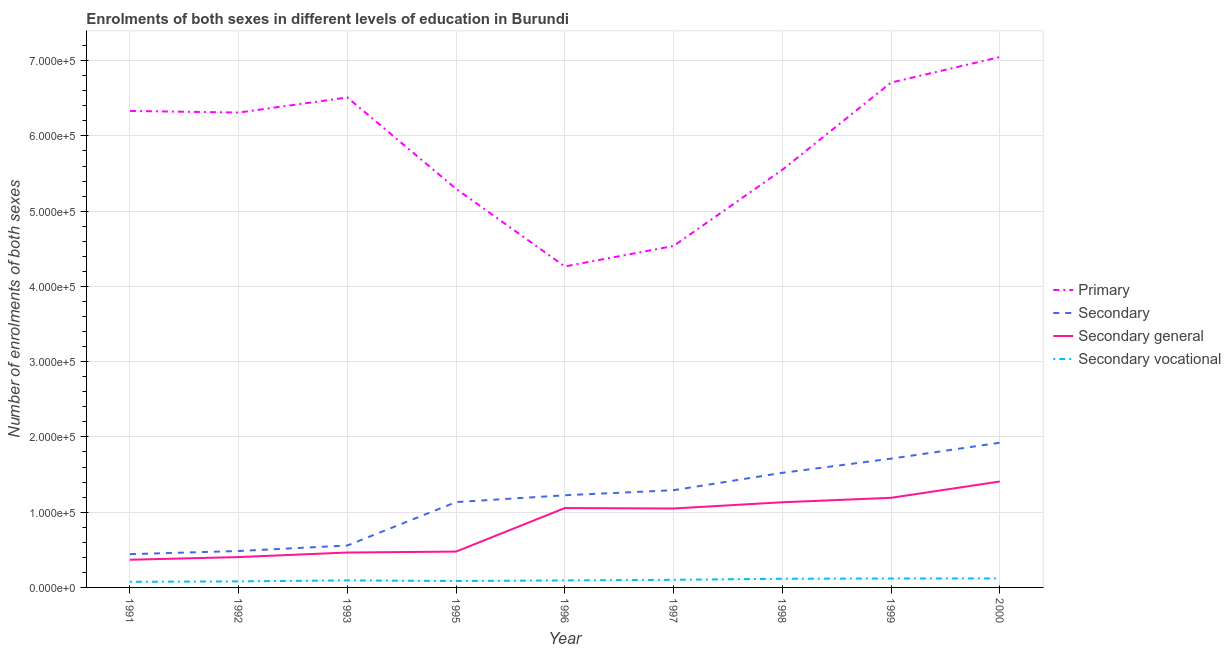How many different coloured lines are there?
Ensure brevity in your answer.  4. What is the number of enrolments in secondary education in 1999?
Provide a succinct answer. 1.71e+05. Across all years, what is the maximum number of enrolments in secondary vocational education?
Give a very brief answer. 1.19e+04. Across all years, what is the minimum number of enrolments in secondary vocational education?
Offer a terse response. 7434. In which year was the number of enrolments in secondary vocational education minimum?
Make the answer very short. 1991. What is the total number of enrolments in secondary vocational education in the graph?
Your answer should be compact. 8.81e+04. What is the difference between the number of enrolments in secondary general education in 1996 and that in 1998?
Your answer should be compact. -7703. What is the difference between the number of enrolments in secondary vocational education in 1993 and the number of enrolments in secondary education in 1998?
Provide a short and direct response. -1.43e+05. What is the average number of enrolments in secondary vocational education per year?
Ensure brevity in your answer.  9787.78. In the year 1997, what is the difference between the number of enrolments in secondary vocational education and number of enrolments in secondary general education?
Give a very brief answer. -9.48e+04. What is the ratio of the number of enrolments in primary education in 1997 to that in 2000?
Provide a succinct answer. 0.64. Is the number of enrolments in secondary general education in 1992 less than that in 1999?
Provide a succinct answer. Yes. What is the difference between the highest and the second highest number of enrolments in secondary vocational education?
Ensure brevity in your answer.  42. What is the difference between the highest and the lowest number of enrolments in secondary education?
Your answer should be compact. 1.48e+05. Is the sum of the number of enrolments in primary education in 1992 and 1997 greater than the maximum number of enrolments in secondary education across all years?
Provide a short and direct response. Yes. Is it the case that in every year, the sum of the number of enrolments in secondary vocational education and number of enrolments in primary education is greater than the sum of number of enrolments in secondary general education and number of enrolments in secondary education?
Provide a succinct answer. Yes. Does the number of enrolments in secondary vocational education monotonically increase over the years?
Ensure brevity in your answer.  No. Is the number of enrolments in secondary general education strictly greater than the number of enrolments in primary education over the years?
Your answer should be compact. No. What is the difference between two consecutive major ticks on the Y-axis?
Provide a short and direct response. 1.00e+05. Are the values on the major ticks of Y-axis written in scientific E-notation?
Your answer should be compact. Yes. Does the graph contain any zero values?
Your response must be concise. No. Does the graph contain grids?
Offer a terse response. Yes. What is the title of the graph?
Your answer should be compact. Enrolments of both sexes in different levels of education in Burundi. What is the label or title of the X-axis?
Offer a very short reply. Year. What is the label or title of the Y-axis?
Make the answer very short. Number of enrolments of both sexes. What is the Number of enrolments of both sexes in Primary in 1991?
Provide a short and direct response. 6.33e+05. What is the Number of enrolments of both sexes in Secondary in 1991?
Ensure brevity in your answer.  4.42e+04. What is the Number of enrolments of both sexes of Secondary general in 1991?
Provide a short and direct response. 3.68e+04. What is the Number of enrolments of both sexes in Secondary vocational in 1991?
Ensure brevity in your answer.  7434. What is the Number of enrolments of both sexes in Primary in 1992?
Your answer should be very brief. 6.31e+05. What is the Number of enrolments of both sexes in Secondary in 1992?
Give a very brief answer. 4.84e+04. What is the Number of enrolments of both sexes in Secondary general in 1992?
Provide a succinct answer. 4.03e+04. What is the Number of enrolments of both sexes of Secondary vocational in 1992?
Ensure brevity in your answer.  8064. What is the Number of enrolments of both sexes in Primary in 1993?
Keep it short and to the point. 6.51e+05. What is the Number of enrolments of both sexes in Secondary in 1993?
Keep it short and to the point. 5.57e+04. What is the Number of enrolments of both sexes of Secondary general in 1993?
Your answer should be compact. 4.64e+04. What is the Number of enrolments of both sexes in Secondary vocational in 1993?
Make the answer very short. 9332. What is the Number of enrolments of both sexes in Primary in 1995?
Your answer should be very brief. 5.30e+05. What is the Number of enrolments of both sexes in Secondary in 1995?
Make the answer very short. 1.13e+05. What is the Number of enrolments of both sexes in Secondary general in 1995?
Offer a very short reply. 4.76e+04. What is the Number of enrolments of both sexes of Secondary vocational in 1995?
Ensure brevity in your answer.  8542. What is the Number of enrolments of both sexes in Primary in 1996?
Ensure brevity in your answer.  4.27e+05. What is the Number of enrolments of both sexes of Secondary in 1996?
Offer a very short reply. 1.22e+05. What is the Number of enrolments of both sexes in Secondary general in 1996?
Provide a short and direct response. 1.05e+05. What is the Number of enrolments of both sexes in Secondary vocational in 1996?
Your answer should be compact. 9293. What is the Number of enrolments of both sexes in Primary in 1997?
Give a very brief answer. 4.54e+05. What is the Number of enrolments of both sexes of Secondary in 1997?
Offer a terse response. 1.29e+05. What is the Number of enrolments of both sexes of Secondary general in 1997?
Your answer should be compact. 1.05e+05. What is the Number of enrolments of both sexes in Secondary vocational in 1997?
Offer a very short reply. 1.01e+04. What is the Number of enrolments of both sexes of Primary in 1998?
Keep it short and to the point. 5.55e+05. What is the Number of enrolments of both sexes in Secondary in 1998?
Ensure brevity in your answer.  1.52e+05. What is the Number of enrolments of both sexes in Secondary general in 1998?
Your answer should be compact. 1.13e+05. What is the Number of enrolments of both sexes in Secondary vocational in 1998?
Ensure brevity in your answer.  1.15e+04. What is the Number of enrolments of both sexes of Primary in 1999?
Keep it short and to the point. 6.71e+05. What is the Number of enrolments of both sexes in Secondary in 1999?
Give a very brief answer. 1.71e+05. What is the Number of enrolments of both sexes in Secondary general in 1999?
Provide a succinct answer. 1.19e+05. What is the Number of enrolments of both sexes of Secondary vocational in 1999?
Offer a terse response. 1.19e+04. What is the Number of enrolments of both sexes of Primary in 2000?
Keep it short and to the point. 7.05e+05. What is the Number of enrolments of both sexes in Secondary in 2000?
Offer a very short reply. 1.92e+05. What is the Number of enrolments of both sexes in Secondary general in 2000?
Offer a very short reply. 1.41e+05. What is the Number of enrolments of both sexes in Secondary vocational in 2000?
Offer a terse response. 1.19e+04. Across all years, what is the maximum Number of enrolments of both sexes in Primary?
Your answer should be very brief. 7.05e+05. Across all years, what is the maximum Number of enrolments of both sexes of Secondary?
Give a very brief answer. 1.92e+05. Across all years, what is the maximum Number of enrolments of both sexes in Secondary general?
Your answer should be very brief. 1.41e+05. Across all years, what is the maximum Number of enrolments of both sexes in Secondary vocational?
Provide a short and direct response. 1.19e+04. Across all years, what is the minimum Number of enrolments of both sexes in Primary?
Make the answer very short. 4.27e+05. Across all years, what is the minimum Number of enrolments of both sexes in Secondary?
Make the answer very short. 4.42e+04. Across all years, what is the minimum Number of enrolments of both sexes in Secondary general?
Your response must be concise. 3.68e+04. Across all years, what is the minimum Number of enrolments of both sexes in Secondary vocational?
Make the answer very short. 7434. What is the total Number of enrolments of both sexes in Primary in the graph?
Give a very brief answer. 5.26e+06. What is the total Number of enrolments of both sexes of Secondary in the graph?
Make the answer very short. 1.03e+06. What is the total Number of enrolments of both sexes in Secondary general in the graph?
Offer a very short reply. 7.54e+05. What is the total Number of enrolments of both sexes in Secondary vocational in the graph?
Offer a very short reply. 8.81e+04. What is the difference between the Number of enrolments of both sexes in Primary in 1991 and that in 1992?
Your answer should be compact. 2164. What is the difference between the Number of enrolments of both sexes in Secondary in 1991 and that in 1992?
Offer a terse response. -4191. What is the difference between the Number of enrolments of both sexes in Secondary general in 1991 and that in 1992?
Your answer should be very brief. -3561. What is the difference between the Number of enrolments of both sexes of Secondary vocational in 1991 and that in 1992?
Provide a short and direct response. -630. What is the difference between the Number of enrolments of both sexes in Primary in 1991 and that in 1993?
Keep it short and to the point. -1.79e+04. What is the difference between the Number of enrolments of both sexes in Secondary in 1991 and that in 1993?
Your answer should be compact. -1.15e+04. What is the difference between the Number of enrolments of both sexes in Secondary general in 1991 and that in 1993?
Provide a succinct answer. -9608. What is the difference between the Number of enrolments of both sexes in Secondary vocational in 1991 and that in 1993?
Ensure brevity in your answer.  -1898. What is the difference between the Number of enrolments of both sexes in Primary in 1991 and that in 1995?
Ensure brevity in your answer.  1.04e+05. What is the difference between the Number of enrolments of both sexes in Secondary in 1991 and that in 1995?
Provide a short and direct response. -6.92e+04. What is the difference between the Number of enrolments of both sexes in Secondary general in 1991 and that in 1995?
Your answer should be very brief. -1.09e+04. What is the difference between the Number of enrolments of both sexes in Secondary vocational in 1991 and that in 1995?
Keep it short and to the point. -1108. What is the difference between the Number of enrolments of both sexes of Primary in 1991 and that in 1996?
Provide a succinct answer. 2.07e+05. What is the difference between the Number of enrolments of both sexes in Secondary in 1991 and that in 1996?
Your answer should be compact. -7.83e+04. What is the difference between the Number of enrolments of both sexes of Secondary general in 1991 and that in 1996?
Make the answer very short. -6.87e+04. What is the difference between the Number of enrolments of both sexes in Secondary vocational in 1991 and that in 1996?
Offer a very short reply. -1859. What is the difference between the Number of enrolments of both sexes in Primary in 1991 and that in 1997?
Your answer should be very brief. 1.79e+05. What is the difference between the Number of enrolments of both sexes in Secondary in 1991 and that in 1997?
Give a very brief answer. -8.50e+04. What is the difference between the Number of enrolments of both sexes of Secondary general in 1991 and that in 1997?
Keep it short and to the point. -6.81e+04. What is the difference between the Number of enrolments of both sexes in Secondary vocational in 1991 and that in 1997?
Make the answer very short. -2693. What is the difference between the Number of enrolments of both sexes in Primary in 1991 and that in 1998?
Give a very brief answer. 7.82e+04. What is the difference between the Number of enrolments of both sexes in Secondary in 1991 and that in 1998?
Make the answer very short. -1.08e+05. What is the difference between the Number of enrolments of both sexes in Secondary general in 1991 and that in 1998?
Offer a terse response. -7.64e+04. What is the difference between the Number of enrolments of both sexes of Secondary vocational in 1991 and that in 1998?
Give a very brief answer. -4082. What is the difference between the Number of enrolments of both sexes of Primary in 1991 and that in 1999?
Give a very brief answer. -3.77e+04. What is the difference between the Number of enrolments of both sexes of Secondary in 1991 and that in 1999?
Offer a terse response. -1.27e+05. What is the difference between the Number of enrolments of both sexes of Secondary general in 1991 and that in 1999?
Your response must be concise. -8.23e+04. What is the difference between the Number of enrolments of both sexes in Secondary vocational in 1991 and that in 1999?
Offer a very short reply. -4436. What is the difference between the Number of enrolments of both sexes in Primary in 1991 and that in 2000?
Ensure brevity in your answer.  -7.16e+04. What is the difference between the Number of enrolments of both sexes in Secondary in 1991 and that in 2000?
Offer a terse response. -1.48e+05. What is the difference between the Number of enrolments of both sexes of Secondary general in 1991 and that in 2000?
Offer a very short reply. -1.04e+05. What is the difference between the Number of enrolments of both sexes in Secondary vocational in 1991 and that in 2000?
Give a very brief answer. -4478. What is the difference between the Number of enrolments of both sexes of Primary in 1992 and that in 1993?
Give a very brief answer. -2.00e+04. What is the difference between the Number of enrolments of both sexes in Secondary in 1992 and that in 1993?
Offer a terse response. -7315. What is the difference between the Number of enrolments of both sexes of Secondary general in 1992 and that in 1993?
Offer a very short reply. -6047. What is the difference between the Number of enrolments of both sexes in Secondary vocational in 1992 and that in 1993?
Ensure brevity in your answer.  -1268. What is the difference between the Number of enrolments of both sexes of Primary in 1992 and that in 1995?
Make the answer very short. 1.01e+05. What is the difference between the Number of enrolments of both sexes in Secondary in 1992 and that in 1995?
Offer a terse response. -6.50e+04. What is the difference between the Number of enrolments of both sexes of Secondary general in 1992 and that in 1995?
Provide a short and direct response. -7302. What is the difference between the Number of enrolments of both sexes of Secondary vocational in 1992 and that in 1995?
Your response must be concise. -478. What is the difference between the Number of enrolments of both sexes in Primary in 1992 and that in 1996?
Keep it short and to the point. 2.05e+05. What is the difference between the Number of enrolments of both sexes in Secondary in 1992 and that in 1996?
Make the answer very short. -7.41e+04. What is the difference between the Number of enrolments of both sexes in Secondary general in 1992 and that in 1996?
Offer a very short reply. -6.51e+04. What is the difference between the Number of enrolments of both sexes of Secondary vocational in 1992 and that in 1996?
Offer a terse response. -1229. What is the difference between the Number of enrolments of both sexes in Primary in 1992 and that in 1997?
Make the answer very short. 1.77e+05. What is the difference between the Number of enrolments of both sexes in Secondary in 1992 and that in 1997?
Make the answer very short. -8.08e+04. What is the difference between the Number of enrolments of both sexes in Secondary general in 1992 and that in 1997?
Ensure brevity in your answer.  -6.46e+04. What is the difference between the Number of enrolments of both sexes in Secondary vocational in 1992 and that in 1997?
Provide a succinct answer. -2063. What is the difference between the Number of enrolments of both sexes in Primary in 1992 and that in 1998?
Ensure brevity in your answer.  7.61e+04. What is the difference between the Number of enrolments of both sexes of Secondary in 1992 and that in 1998?
Provide a short and direct response. -1.04e+05. What is the difference between the Number of enrolments of both sexes in Secondary general in 1992 and that in 1998?
Ensure brevity in your answer.  -7.28e+04. What is the difference between the Number of enrolments of both sexes of Secondary vocational in 1992 and that in 1998?
Offer a very short reply. -3452. What is the difference between the Number of enrolments of both sexes of Primary in 1992 and that in 1999?
Give a very brief answer. -3.98e+04. What is the difference between the Number of enrolments of both sexes of Secondary in 1992 and that in 1999?
Ensure brevity in your answer.  -1.23e+05. What is the difference between the Number of enrolments of both sexes of Secondary general in 1992 and that in 1999?
Offer a terse response. -7.87e+04. What is the difference between the Number of enrolments of both sexes of Secondary vocational in 1992 and that in 1999?
Keep it short and to the point. -3806. What is the difference between the Number of enrolments of both sexes of Primary in 1992 and that in 2000?
Your answer should be very brief. -7.37e+04. What is the difference between the Number of enrolments of both sexes in Secondary in 1992 and that in 2000?
Offer a terse response. -1.44e+05. What is the difference between the Number of enrolments of both sexes in Secondary general in 1992 and that in 2000?
Make the answer very short. -1.00e+05. What is the difference between the Number of enrolments of both sexes of Secondary vocational in 1992 and that in 2000?
Make the answer very short. -3848. What is the difference between the Number of enrolments of both sexes of Primary in 1993 and that in 1995?
Make the answer very short. 1.21e+05. What is the difference between the Number of enrolments of both sexes of Secondary in 1993 and that in 1995?
Provide a short and direct response. -5.77e+04. What is the difference between the Number of enrolments of both sexes of Secondary general in 1993 and that in 1995?
Keep it short and to the point. -1255. What is the difference between the Number of enrolments of both sexes of Secondary vocational in 1993 and that in 1995?
Give a very brief answer. 790. What is the difference between the Number of enrolments of both sexes of Primary in 1993 and that in 1996?
Your answer should be very brief. 2.25e+05. What is the difference between the Number of enrolments of both sexes of Secondary in 1993 and that in 1996?
Your answer should be very brief. -6.68e+04. What is the difference between the Number of enrolments of both sexes of Secondary general in 1993 and that in 1996?
Offer a very short reply. -5.91e+04. What is the difference between the Number of enrolments of both sexes in Primary in 1993 and that in 1997?
Offer a very short reply. 1.97e+05. What is the difference between the Number of enrolments of both sexes in Secondary in 1993 and that in 1997?
Provide a succinct answer. -7.35e+04. What is the difference between the Number of enrolments of both sexes of Secondary general in 1993 and that in 1997?
Provide a short and direct response. -5.85e+04. What is the difference between the Number of enrolments of both sexes in Secondary vocational in 1993 and that in 1997?
Keep it short and to the point. -795. What is the difference between the Number of enrolments of both sexes in Primary in 1993 and that in 1998?
Ensure brevity in your answer.  9.61e+04. What is the difference between the Number of enrolments of both sexes in Secondary in 1993 and that in 1998?
Make the answer very short. -9.65e+04. What is the difference between the Number of enrolments of both sexes in Secondary general in 1993 and that in 1998?
Offer a very short reply. -6.68e+04. What is the difference between the Number of enrolments of both sexes in Secondary vocational in 1993 and that in 1998?
Your answer should be compact. -2184. What is the difference between the Number of enrolments of both sexes of Primary in 1993 and that in 1999?
Offer a very short reply. -1.98e+04. What is the difference between the Number of enrolments of both sexes in Secondary in 1993 and that in 1999?
Provide a succinct answer. -1.15e+05. What is the difference between the Number of enrolments of both sexes in Secondary general in 1993 and that in 1999?
Offer a terse response. -7.27e+04. What is the difference between the Number of enrolments of both sexes of Secondary vocational in 1993 and that in 1999?
Make the answer very short. -2538. What is the difference between the Number of enrolments of both sexes of Primary in 1993 and that in 2000?
Your response must be concise. -5.37e+04. What is the difference between the Number of enrolments of both sexes of Secondary in 1993 and that in 2000?
Offer a very short reply. -1.37e+05. What is the difference between the Number of enrolments of both sexes in Secondary general in 1993 and that in 2000?
Provide a succinct answer. -9.44e+04. What is the difference between the Number of enrolments of both sexes in Secondary vocational in 1993 and that in 2000?
Your answer should be compact. -2580. What is the difference between the Number of enrolments of both sexes in Primary in 1995 and that in 1996?
Your response must be concise. 1.03e+05. What is the difference between the Number of enrolments of both sexes of Secondary in 1995 and that in 1996?
Offer a terse response. -9042. What is the difference between the Number of enrolments of both sexes of Secondary general in 1995 and that in 1996?
Offer a terse response. -5.78e+04. What is the difference between the Number of enrolments of both sexes in Secondary vocational in 1995 and that in 1996?
Your answer should be very brief. -751. What is the difference between the Number of enrolments of both sexes in Primary in 1995 and that in 1997?
Keep it short and to the point. 7.59e+04. What is the difference between the Number of enrolments of both sexes in Secondary in 1995 and that in 1997?
Provide a short and direct response. -1.58e+04. What is the difference between the Number of enrolments of both sexes of Secondary general in 1995 and that in 1997?
Offer a terse response. -5.72e+04. What is the difference between the Number of enrolments of both sexes of Secondary vocational in 1995 and that in 1997?
Give a very brief answer. -1585. What is the difference between the Number of enrolments of both sexes in Primary in 1995 and that in 1998?
Provide a succinct answer. -2.53e+04. What is the difference between the Number of enrolments of both sexes of Secondary in 1995 and that in 1998?
Your answer should be compact. -3.88e+04. What is the difference between the Number of enrolments of both sexes of Secondary general in 1995 and that in 1998?
Offer a terse response. -6.55e+04. What is the difference between the Number of enrolments of both sexes of Secondary vocational in 1995 and that in 1998?
Provide a short and direct response. -2974. What is the difference between the Number of enrolments of both sexes in Primary in 1995 and that in 1999?
Your response must be concise. -1.41e+05. What is the difference between the Number of enrolments of both sexes in Secondary in 1995 and that in 1999?
Your answer should be compact. -5.77e+04. What is the difference between the Number of enrolments of both sexes in Secondary general in 1995 and that in 1999?
Make the answer very short. -7.14e+04. What is the difference between the Number of enrolments of both sexes in Secondary vocational in 1995 and that in 1999?
Provide a succinct answer. -3328. What is the difference between the Number of enrolments of both sexes in Primary in 1995 and that in 2000?
Your answer should be very brief. -1.75e+05. What is the difference between the Number of enrolments of both sexes of Secondary in 1995 and that in 2000?
Give a very brief answer. -7.89e+04. What is the difference between the Number of enrolments of both sexes in Secondary general in 1995 and that in 2000?
Ensure brevity in your answer.  -9.31e+04. What is the difference between the Number of enrolments of both sexes of Secondary vocational in 1995 and that in 2000?
Provide a succinct answer. -3370. What is the difference between the Number of enrolments of both sexes of Primary in 1996 and that in 1997?
Make the answer very short. -2.72e+04. What is the difference between the Number of enrolments of both sexes of Secondary in 1996 and that in 1997?
Offer a terse response. -6735. What is the difference between the Number of enrolments of both sexes in Secondary general in 1996 and that in 1997?
Offer a terse response. 588. What is the difference between the Number of enrolments of both sexes of Secondary vocational in 1996 and that in 1997?
Give a very brief answer. -834. What is the difference between the Number of enrolments of both sexes in Primary in 1996 and that in 1998?
Give a very brief answer. -1.28e+05. What is the difference between the Number of enrolments of both sexes in Secondary in 1996 and that in 1998?
Offer a terse response. -2.98e+04. What is the difference between the Number of enrolments of both sexes in Secondary general in 1996 and that in 1998?
Offer a terse response. -7703. What is the difference between the Number of enrolments of both sexes of Secondary vocational in 1996 and that in 1998?
Ensure brevity in your answer.  -2223. What is the difference between the Number of enrolments of both sexes in Primary in 1996 and that in 1999?
Provide a succinct answer. -2.44e+05. What is the difference between the Number of enrolments of both sexes in Secondary in 1996 and that in 1999?
Offer a terse response. -4.86e+04. What is the difference between the Number of enrolments of both sexes of Secondary general in 1996 and that in 1999?
Offer a very short reply. -1.36e+04. What is the difference between the Number of enrolments of both sexes in Secondary vocational in 1996 and that in 1999?
Provide a short and direct response. -2577. What is the difference between the Number of enrolments of both sexes in Primary in 1996 and that in 2000?
Your response must be concise. -2.78e+05. What is the difference between the Number of enrolments of both sexes of Secondary in 1996 and that in 2000?
Provide a succinct answer. -6.98e+04. What is the difference between the Number of enrolments of both sexes of Secondary general in 1996 and that in 2000?
Make the answer very short. -3.53e+04. What is the difference between the Number of enrolments of both sexes in Secondary vocational in 1996 and that in 2000?
Make the answer very short. -2619. What is the difference between the Number of enrolments of both sexes in Primary in 1997 and that in 1998?
Provide a succinct answer. -1.01e+05. What is the difference between the Number of enrolments of both sexes in Secondary in 1997 and that in 1998?
Keep it short and to the point. -2.30e+04. What is the difference between the Number of enrolments of both sexes of Secondary general in 1997 and that in 1998?
Offer a terse response. -8291. What is the difference between the Number of enrolments of both sexes in Secondary vocational in 1997 and that in 1998?
Your answer should be very brief. -1389. What is the difference between the Number of enrolments of both sexes of Primary in 1997 and that in 1999?
Give a very brief answer. -2.17e+05. What is the difference between the Number of enrolments of both sexes of Secondary in 1997 and that in 1999?
Provide a succinct answer. -4.19e+04. What is the difference between the Number of enrolments of both sexes in Secondary general in 1997 and that in 1999?
Make the answer very short. -1.42e+04. What is the difference between the Number of enrolments of both sexes in Secondary vocational in 1997 and that in 1999?
Your answer should be compact. -1743. What is the difference between the Number of enrolments of both sexes of Primary in 1997 and that in 2000?
Make the answer very short. -2.51e+05. What is the difference between the Number of enrolments of both sexes of Secondary in 1997 and that in 2000?
Your answer should be compact. -6.31e+04. What is the difference between the Number of enrolments of both sexes of Secondary general in 1997 and that in 2000?
Ensure brevity in your answer.  -3.58e+04. What is the difference between the Number of enrolments of both sexes of Secondary vocational in 1997 and that in 2000?
Provide a succinct answer. -1785. What is the difference between the Number of enrolments of both sexes of Primary in 1998 and that in 1999?
Keep it short and to the point. -1.16e+05. What is the difference between the Number of enrolments of both sexes of Secondary in 1998 and that in 1999?
Keep it short and to the point. -1.89e+04. What is the difference between the Number of enrolments of both sexes of Secondary general in 1998 and that in 1999?
Your answer should be very brief. -5901. What is the difference between the Number of enrolments of both sexes in Secondary vocational in 1998 and that in 1999?
Provide a succinct answer. -354. What is the difference between the Number of enrolments of both sexes of Primary in 1998 and that in 2000?
Your response must be concise. -1.50e+05. What is the difference between the Number of enrolments of both sexes in Secondary in 1998 and that in 2000?
Give a very brief answer. -4.00e+04. What is the difference between the Number of enrolments of both sexes of Secondary general in 1998 and that in 2000?
Keep it short and to the point. -2.76e+04. What is the difference between the Number of enrolments of both sexes of Secondary vocational in 1998 and that in 2000?
Provide a succinct answer. -396. What is the difference between the Number of enrolments of both sexes of Primary in 1999 and that in 2000?
Your response must be concise. -3.39e+04. What is the difference between the Number of enrolments of both sexes in Secondary in 1999 and that in 2000?
Offer a terse response. -2.12e+04. What is the difference between the Number of enrolments of both sexes of Secondary general in 1999 and that in 2000?
Your answer should be very brief. -2.17e+04. What is the difference between the Number of enrolments of both sexes in Secondary vocational in 1999 and that in 2000?
Provide a short and direct response. -42. What is the difference between the Number of enrolments of both sexes in Primary in 1991 and the Number of enrolments of both sexes in Secondary in 1992?
Ensure brevity in your answer.  5.85e+05. What is the difference between the Number of enrolments of both sexes of Primary in 1991 and the Number of enrolments of both sexes of Secondary general in 1992?
Provide a short and direct response. 5.93e+05. What is the difference between the Number of enrolments of both sexes in Primary in 1991 and the Number of enrolments of both sexes in Secondary vocational in 1992?
Your answer should be very brief. 6.25e+05. What is the difference between the Number of enrolments of both sexes of Secondary in 1991 and the Number of enrolments of both sexes of Secondary general in 1992?
Your response must be concise. 3873. What is the difference between the Number of enrolments of both sexes in Secondary in 1991 and the Number of enrolments of both sexes in Secondary vocational in 1992?
Your answer should be very brief. 3.61e+04. What is the difference between the Number of enrolments of both sexes in Secondary general in 1991 and the Number of enrolments of both sexes in Secondary vocational in 1992?
Provide a short and direct response. 2.87e+04. What is the difference between the Number of enrolments of both sexes of Primary in 1991 and the Number of enrolments of both sexes of Secondary in 1993?
Give a very brief answer. 5.77e+05. What is the difference between the Number of enrolments of both sexes in Primary in 1991 and the Number of enrolments of both sexes in Secondary general in 1993?
Keep it short and to the point. 5.87e+05. What is the difference between the Number of enrolments of both sexes in Primary in 1991 and the Number of enrolments of both sexes in Secondary vocational in 1993?
Your response must be concise. 6.24e+05. What is the difference between the Number of enrolments of both sexes of Secondary in 1991 and the Number of enrolments of both sexes of Secondary general in 1993?
Your answer should be compact. -2174. What is the difference between the Number of enrolments of both sexes in Secondary in 1991 and the Number of enrolments of both sexes in Secondary vocational in 1993?
Make the answer very short. 3.49e+04. What is the difference between the Number of enrolments of both sexes in Secondary general in 1991 and the Number of enrolments of both sexes in Secondary vocational in 1993?
Provide a succinct answer. 2.74e+04. What is the difference between the Number of enrolments of both sexes of Primary in 1991 and the Number of enrolments of both sexes of Secondary in 1995?
Offer a very short reply. 5.20e+05. What is the difference between the Number of enrolments of both sexes of Primary in 1991 and the Number of enrolments of both sexes of Secondary general in 1995?
Ensure brevity in your answer.  5.86e+05. What is the difference between the Number of enrolments of both sexes of Primary in 1991 and the Number of enrolments of both sexes of Secondary vocational in 1995?
Ensure brevity in your answer.  6.25e+05. What is the difference between the Number of enrolments of both sexes in Secondary in 1991 and the Number of enrolments of both sexes in Secondary general in 1995?
Provide a short and direct response. -3429. What is the difference between the Number of enrolments of both sexes in Secondary in 1991 and the Number of enrolments of both sexes in Secondary vocational in 1995?
Provide a succinct answer. 3.57e+04. What is the difference between the Number of enrolments of both sexes in Secondary general in 1991 and the Number of enrolments of both sexes in Secondary vocational in 1995?
Offer a terse response. 2.82e+04. What is the difference between the Number of enrolments of both sexes in Primary in 1991 and the Number of enrolments of both sexes in Secondary in 1996?
Your response must be concise. 5.11e+05. What is the difference between the Number of enrolments of both sexes of Primary in 1991 and the Number of enrolments of both sexes of Secondary general in 1996?
Provide a succinct answer. 5.28e+05. What is the difference between the Number of enrolments of both sexes of Primary in 1991 and the Number of enrolments of both sexes of Secondary vocational in 1996?
Provide a short and direct response. 6.24e+05. What is the difference between the Number of enrolments of both sexes of Secondary in 1991 and the Number of enrolments of both sexes of Secondary general in 1996?
Offer a very short reply. -6.13e+04. What is the difference between the Number of enrolments of both sexes in Secondary in 1991 and the Number of enrolments of both sexes in Secondary vocational in 1996?
Provide a succinct answer. 3.49e+04. What is the difference between the Number of enrolments of both sexes of Secondary general in 1991 and the Number of enrolments of both sexes of Secondary vocational in 1996?
Provide a succinct answer. 2.75e+04. What is the difference between the Number of enrolments of both sexes of Primary in 1991 and the Number of enrolments of both sexes of Secondary in 1997?
Keep it short and to the point. 5.04e+05. What is the difference between the Number of enrolments of both sexes of Primary in 1991 and the Number of enrolments of both sexes of Secondary general in 1997?
Your answer should be very brief. 5.28e+05. What is the difference between the Number of enrolments of both sexes of Primary in 1991 and the Number of enrolments of both sexes of Secondary vocational in 1997?
Ensure brevity in your answer.  6.23e+05. What is the difference between the Number of enrolments of both sexes in Secondary in 1991 and the Number of enrolments of both sexes in Secondary general in 1997?
Your response must be concise. -6.07e+04. What is the difference between the Number of enrolments of both sexes of Secondary in 1991 and the Number of enrolments of both sexes of Secondary vocational in 1997?
Your answer should be compact. 3.41e+04. What is the difference between the Number of enrolments of both sexes in Secondary general in 1991 and the Number of enrolments of both sexes in Secondary vocational in 1997?
Your answer should be very brief. 2.66e+04. What is the difference between the Number of enrolments of both sexes in Primary in 1991 and the Number of enrolments of both sexes in Secondary in 1998?
Offer a very short reply. 4.81e+05. What is the difference between the Number of enrolments of both sexes of Primary in 1991 and the Number of enrolments of both sexes of Secondary general in 1998?
Your answer should be compact. 5.20e+05. What is the difference between the Number of enrolments of both sexes of Primary in 1991 and the Number of enrolments of both sexes of Secondary vocational in 1998?
Give a very brief answer. 6.22e+05. What is the difference between the Number of enrolments of both sexes in Secondary in 1991 and the Number of enrolments of both sexes in Secondary general in 1998?
Your answer should be compact. -6.90e+04. What is the difference between the Number of enrolments of both sexes in Secondary in 1991 and the Number of enrolments of both sexes in Secondary vocational in 1998?
Ensure brevity in your answer.  3.27e+04. What is the difference between the Number of enrolments of both sexes in Secondary general in 1991 and the Number of enrolments of both sexes in Secondary vocational in 1998?
Provide a short and direct response. 2.53e+04. What is the difference between the Number of enrolments of both sexes of Primary in 1991 and the Number of enrolments of both sexes of Secondary in 1999?
Offer a very short reply. 4.62e+05. What is the difference between the Number of enrolments of both sexes in Primary in 1991 and the Number of enrolments of both sexes in Secondary general in 1999?
Provide a succinct answer. 5.14e+05. What is the difference between the Number of enrolments of both sexes of Primary in 1991 and the Number of enrolments of both sexes of Secondary vocational in 1999?
Provide a succinct answer. 6.21e+05. What is the difference between the Number of enrolments of both sexes in Secondary in 1991 and the Number of enrolments of both sexes in Secondary general in 1999?
Give a very brief answer. -7.49e+04. What is the difference between the Number of enrolments of both sexes in Secondary in 1991 and the Number of enrolments of both sexes in Secondary vocational in 1999?
Provide a short and direct response. 3.23e+04. What is the difference between the Number of enrolments of both sexes of Secondary general in 1991 and the Number of enrolments of both sexes of Secondary vocational in 1999?
Make the answer very short. 2.49e+04. What is the difference between the Number of enrolments of both sexes in Primary in 1991 and the Number of enrolments of both sexes in Secondary in 2000?
Keep it short and to the point. 4.41e+05. What is the difference between the Number of enrolments of both sexes of Primary in 1991 and the Number of enrolments of both sexes of Secondary general in 2000?
Provide a short and direct response. 4.92e+05. What is the difference between the Number of enrolments of both sexes in Primary in 1991 and the Number of enrolments of both sexes in Secondary vocational in 2000?
Give a very brief answer. 6.21e+05. What is the difference between the Number of enrolments of both sexes of Secondary in 1991 and the Number of enrolments of both sexes of Secondary general in 2000?
Keep it short and to the point. -9.65e+04. What is the difference between the Number of enrolments of both sexes of Secondary in 1991 and the Number of enrolments of both sexes of Secondary vocational in 2000?
Your answer should be very brief. 3.23e+04. What is the difference between the Number of enrolments of both sexes in Secondary general in 1991 and the Number of enrolments of both sexes in Secondary vocational in 2000?
Your answer should be very brief. 2.49e+04. What is the difference between the Number of enrolments of both sexes in Primary in 1992 and the Number of enrolments of both sexes in Secondary in 1993?
Provide a succinct answer. 5.75e+05. What is the difference between the Number of enrolments of both sexes of Primary in 1992 and the Number of enrolments of both sexes of Secondary general in 1993?
Your response must be concise. 5.85e+05. What is the difference between the Number of enrolments of both sexes in Primary in 1992 and the Number of enrolments of both sexes in Secondary vocational in 1993?
Give a very brief answer. 6.22e+05. What is the difference between the Number of enrolments of both sexes in Secondary in 1992 and the Number of enrolments of both sexes in Secondary general in 1993?
Give a very brief answer. 2017. What is the difference between the Number of enrolments of both sexes in Secondary in 1992 and the Number of enrolments of both sexes in Secondary vocational in 1993?
Provide a succinct answer. 3.91e+04. What is the difference between the Number of enrolments of both sexes in Secondary general in 1992 and the Number of enrolments of both sexes in Secondary vocational in 1993?
Provide a short and direct response. 3.10e+04. What is the difference between the Number of enrolments of both sexes of Primary in 1992 and the Number of enrolments of both sexes of Secondary in 1995?
Give a very brief answer. 5.18e+05. What is the difference between the Number of enrolments of both sexes in Primary in 1992 and the Number of enrolments of both sexes in Secondary general in 1995?
Your answer should be compact. 5.83e+05. What is the difference between the Number of enrolments of both sexes in Primary in 1992 and the Number of enrolments of both sexes in Secondary vocational in 1995?
Keep it short and to the point. 6.22e+05. What is the difference between the Number of enrolments of both sexes in Secondary in 1992 and the Number of enrolments of both sexes in Secondary general in 1995?
Offer a terse response. 762. What is the difference between the Number of enrolments of both sexes of Secondary in 1992 and the Number of enrolments of both sexes of Secondary vocational in 1995?
Offer a very short reply. 3.99e+04. What is the difference between the Number of enrolments of both sexes in Secondary general in 1992 and the Number of enrolments of both sexes in Secondary vocational in 1995?
Provide a succinct answer. 3.18e+04. What is the difference between the Number of enrolments of both sexes in Primary in 1992 and the Number of enrolments of both sexes in Secondary in 1996?
Offer a very short reply. 5.09e+05. What is the difference between the Number of enrolments of both sexes of Primary in 1992 and the Number of enrolments of both sexes of Secondary general in 1996?
Provide a succinct answer. 5.26e+05. What is the difference between the Number of enrolments of both sexes in Primary in 1992 and the Number of enrolments of both sexes in Secondary vocational in 1996?
Keep it short and to the point. 6.22e+05. What is the difference between the Number of enrolments of both sexes of Secondary in 1992 and the Number of enrolments of both sexes of Secondary general in 1996?
Make the answer very short. -5.71e+04. What is the difference between the Number of enrolments of both sexes of Secondary in 1992 and the Number of enrolments of both sexes of Secondary vocational in 1996?
Offer a terse response. 3.91e+04. What is the difference between the Number of enrolments of both sexes in Secondary general in 1992 and the Number of enrolments of both sexes in Secondary vocational in 1996?
Keep it short and to the point. 3.10e+04. What is the difference between the Number of enrolments of both sexes of Primary in 1992 and the Number of enrolments of both sexes of Secondary in 1997?
Offer a terse response. 5.02e+05. What is the difference between the Number of enrolments of both sexes of Primary in 1992 and the Number of enrolments of both sexes of Secondary general in 1997?
Keep it short and to the point. 5.26e+05. What is the difference between the Number of enrolments of both sexes of Primary in 1992 and the Number of enrolments of both sexes of Secondary vocational in 1997?
Your response must be concise. 6.21e+05. What is the difference between the Number of enrolments of both sexes of Secondary in 1992 and the Number of enrolments of both sexes of Secondary general in 1997?
Your answer should be compact. -5.65e+04. What is the difference between the Number of enrolments of both sexes of Secondary in 1992 and the Number of enrolments of both sexes of Secondary vocational in 1997?
Provide a short and direct response. 3.83e+04. What is the difference between the Number of enrolments of both sexes in Secondary general in 1992 and the Number of enrolments of both sexes in Secondary vocational in 1997?
Provide a short and direct response. 3.02e+04. What is the difference between the Number of enrolments of both sexes in Primary in 1992 and the Number of enrolments of both sexes in Secondary in 1998?
Make the answer very short. 4.79e+05. What is the difference between the Number of enrolments of both sexes in Primary in 1992 and the Number of enrolments of both sexes in Secondary general in 1998?
Your answer should be very brief. 5.18e+05. What is the difference between the Number of enrolments of both sexes of Primary in 1992 and the Number of enrolments of both sexes of Secondary vocational in 1998?
Your answer should be compact. 6.20e+05. What is the difference between the Number of enrolments of both sexes of Secondary in 1992 and the Number of enrolments of both sexes of Secondary general in 1998?
Keep it short and to the point. -6.48e+04. What is the difference between the Number of enrolments of both sexes of Secondary in 1992 and the Number of enrolments of both sexes of Secondary vocational in 1998?
Provide a short and direct response. 3.69e+04. What is the difference between the Number of enrolments of both sexes in Secondary general in 1992 and the Number of enrolments of both sexes in Secondary vocational in 1998?
Provide a succinct answer. 2.88e+04. What is the difference between the Number of enrolments of both sexes of Primary in 1992 and the Number of enrolments of both sexes of Secondary in 1999?
Offer a very short reply. 4.60e+05. What is the difference between the Number of enrolments of both sexes in Primary in 1992 and the Number of enrolments of both sexes in Secondary general in 1999?
Your response must be concise. 5.12e+05. What is the difference between the Number of enrolments of both sexes of Primary in 1992 and the Number of enrolments of both sexes of Secondary vocational in 1999?
Provide a succinct answer. 6.19e+05. What is the difference between the Number of enrolments of both sexes of Secondary in 1992 and the Number of enrolments of both sexes of Secondary general in 1999?
Offer a terse response. -7.07e+04. What is the difference between the Number of enrolments of both sexes in Secondary in 1992 and the Number of enrolments of both sexes in Secondary vocational in 1999?
Offer a very short reply. 3.65e+04. What is the difference between the Number of enrolments of both sexes of Secondary general in 1992 and the Number of enrolments of both sexes of Secondary vocational in 1999?
Provide a short and direct response. 2.85e+04. What is the difference between the Number of enrolments of both sexes of Primary in 1992 and the Number of enrolments of both sexes of Secondary in 2000?
Provide a succinct answer. 4.39e+05. What is the difference between the Number of enrolments of both sexes of Primary in 1992 and the Number of enrolments of both sexes of Secondary general in 2000?
Offer a terse response. 4.90e+05. What is the difference between the Number of enrolments of both sexes in Primary in 1992 and the Number of enrolments of both sexes in Secondary vocational in 2000?
Your answer should be very brief. 6.19e+05. What is the difference between the Number of enrolments of both sexes in Secondary in 1992 and the Number of enrolments of both sexes in Secondary general in 2000?
Offer a very short reply. -9.23e+04. What is the difference between the Number of enrolments of both sexes in Secondary in 1992 and the Number of enrolments of both sexes in Secondary vocational in 2000?
Give a very brief answer. 3.65e+04. What is the difference between the Number of enrolments of both sexes in Secondary general in 1992 and the Number of enrolments of both sexes in Secondary vocational in 2000?
Offer a terse response. 2.84e+04. What is the difference between the Number of enrolments of both sexes in Primary in 1993 and the Number of enrolments of both sexes in Secondary in 1995?
Provide a succinct answer. 5.38e+05. What is the difference between the Number of enrolments of both sexes of Primary in 1993 and the Number of enrolments of both sexes of Secondary general in 1995?
Offer a terse response. 6.03e+05. What is the difference between the Number of enrolments of both sexes in Primary in 1993 and the Number of enrolments of both sexes in Secondary vocational in 1995?
Provide a succinct answer. 6.43e+05. What is the difference between the Number of enrolments of both sexes of Secondary in 1993 and the Number of enrolments of both sexes of Secondary general in 1995?
Provide a short and direct response. 8077. What is the difference between the Number of enrolments of both sexes of Secondary in 1993 and the Number of enrolments of both sexes of Secondary vocational in 1995?
Offer a terse response. 4.72e+04. What is the difference between the Number of enrolments of both sexes in Secondary general in 1993 and the Number of enrolments of both sexes in Secondary vocational in 1995?
Provide a succinct answer. 3.78e+04. What is the difference between the Number of enrolments of both sexes in Primary in 1993 and the Number of enrolments of both sexes in Secondary in 1996?
Keep it short and to the point. 5.29e+05. What is the difference between the Number of enrolments of both sexes in Primary in 1993 and the Number of enrolments of both sexes in Secondary general in 1996?
Make the answer very short. 5.46e+05. What is the difference between the Number of enrolments of both sexes in Primary in 1993 and the Number of enrolments of both sexes in Secondary vocational in 1996?
Provide a short and direct response. 6.42e+05. What is the difference between the Number of enrolments of both sexes in Secondary in 1993 and the Number of enrolments of both sexes in Secondary general in 1996?
Your answer should be very brief. -4.98e+04. What is the difference between the Number of enrolments of both sexes in Secondary in 1993 and the Number of enrolments of both sexes in Secondary vocational in 1996?
Offer a terse response. 4.64e+04. What is the difference between the Number of enrolments of both sexes in Secondary general in 1993 and the Number of enrolments of both sexes in Secondary vocational in 1996?
Make the answer very short. 3.71e+04. What is the difference between the Number of enrolments of both sexes in Primary in 1993 and the Number of enrolments of both sexes in Secondary in 1997?
Ensure brevity in your answer.  5.22e+05. What is the difference between the Number of enrolments of both sexes in Primary in 1993 and the Number of enrolments of both sexes in Secondary general in 1997?
Your answer should be very brief. 5.46e+05. What is the difference between the Number of enrolments of both sexes of Primary in 1993 and the Number of enrolments of both sexes of Secondary vocational in 1997?
Provide a short and direct response. 6.41e+05. What is the difference between the Number of enrolments of both sexes in Secondary in 1993 and the Number of enrolments of both sexes in Secondary general in 1997?
Your response must be concise. -4.92e+04. What is the difference between the Number of enrolments of both sexes of Secondary in 1993 and the Number of enrolments of both sexes of Secondary vocational in 1997?
Offer a very short reply. 4.56e+04. What is the difference between the Number of enrolments of both sexes of Secondary general in 1993 and the Number of enrolments of both sexes of Secondary vocational in 1997?
Provide a succinct answer. 3.63e+04. What is the difference between the Number of enrolments of both sexes of Primary in 1993 and the Number of enrolments of both sexes of Secondary in 1998?
Offer a very short reply. 4.99e+05. What is the difference between the Number of enrolments of both sexes of Primary in 1993 and the Number of enrolments of both sexes of Secondary general in 1998?
Offer a very short reply. 5.38e+05. What is the difference between the Number of enrolments of both sexes of Primary in 1993 and the Number of enrolments of both sexes of Secondary vocational in 1998?
Keep it short and to the point. 6.40e+05. What is the difference between the Number of enrolments of both sexes of Secondary in 1993 and the Number of enrolments of both sexes of Secondary general in 1998?
Keep it short and to the point. -5.75e+04. What is the difference between the Number of enrolments of both sexes of Secondary in 1993 and the Number of enrolments of both sexes of Secondary vocational in 1998?
Make the answer very short. 4.42e+04. What is the difference between the Number of enrolments of both sexes of Secondary general in 1993 and the Number of enrolments of both sexes of Secondary vocational in 1998?
Provide a short and direct response. 3.49e+04. What is the difference between the Number of enrolments of both sexes in Primary in 1993 and the Number of enrolments of both sexes in Secondary in 1999?
Your answer should be very brief. 4.80e+05. What is the difference between the Number of enrolments of both sexes in Primary in 1993 and the Number of enrolments of both sexes in Secondary general in 1999?
Give a very brief answer. 5.32e+05. What is the difference between the Number of enrolments of both sexes of Primary in 1993 and the Number of enrolments of both sexes of Secondary vocational in 1999?
Provide a short and direct response. 6.39e+05. What is the difference between the Number of enrolments of both sexes of Secondary in 1993 and the Number of enrolments of both sexes of Secondary general in 1999?
Give a very brief answer. -6.34e+04. What is the difference between the Number of enrolments of both sexes in Secondary in 1993 and the Number of enrolments of both sexes in Secondary vocational in 1999?
Your answer should be compact. 4.38e+04. What is the difference between the Number of enrolments of both sexes of Secondary general in 1993 and the Number of enrolments of both sexes of Secondary vocational in 1999?
Your response must be concise. 3.45e+04. What is the difference between the Number of enrolments of both sexes in Primary in 1993 and the Number of enrolments of both sexes in Secondary in 2000?
Provide a succinct answer. 4.59e+05. What is the difference between the Number of enrolments of both sexes of Primary in 1993 and the Number of enrolments of both sexes of Secondary general in 2000?
Provide a short and direct response. 5.10e+05. What is the difference between the Number of enrolments of both sexes in Primary in 1993 and the Number of enrolments of both sexes in Secondary vocational in 2000?
Make the answer very short. 6.39e+05. What is the difference between the Number of enrolments of both sexes in Secondary in 1993 and the Number of enrolments of both sexes in Secondary general in 2000?
Your answer should be compact. -8.50e+04. What is the difference between the Number of enrolments of both sexes of Secondary in 1993 and the Number of enrolments of both sexes of Secondary vocational in 2000?
Offer a terse response. 4.38e+04. What is the difference between the Number of enrolments of both sexes of Secondary general in 1993 and the Number of enrolments of both sexes of Secondary vocational in 2000?
Offer a terse response. 3.45e+04. What is the difference between the Number of enrolments of both sexes of Primary in 1995 and the Number of enrolments of both sexes of Secondary in 1996?
Offer a terse response. 4.07e+05. What is the difference between the Number of enrolments of both sexes of Primary in 1995 and the Number of enrolments of both sexes of Secondary general in 1996?
Your response must be concise. 4.24e+05. What is the difference between the Number of enrolments of both sexes in Primary in 1995 and the Number of enrolments of both sexes in Secondary vocational in 1996?
Your response must be concise. 5.20e+05. What is the difference between the Number of enrolments of both sexes of Secondary in 1995 and the Number of enrolments of both sexes of Secondary general in 1996?
Your answer should be compact. 7954. What is the difference between the Number of enrolments of both sexes of Secondary in 1995 and the Number of enrolments of both sexes of Secondary vocational in 1996?
Give a very brief answer. 1.04e+05. What is the difference between the Number of enrolments of both sexes of Secondary general in 1995 and the Number of enrolments of both sexes of Secondary vocational in 1996?
Provide a succinct answer. 3.83e+04. What is the difference between the Number of enrolments of both sexes in Primary in 1995 and the Number of enrolments of both sexes in Secondary in 1997?
Offer a very short reply. 4.00e+05. What is the difference between the Number of enrolments of both sexes in Primary in 1995 and the Number of enrolments of both sexes in Secondary general in 1997?
Your answer should be very brief. 4.25e+05. What is the difference between the Number of enrolments of both sexes of Primary in 1995 and the Number of enrolments of both sexes of Secondary vocational in 1997?
Your answer should be very brief. 5.20e+05. What is the difference between the Number of enrolments of both sexes of Secondary in 1995 and the Number of enrolments of both sexes of Secondary general in 1997?
Give a very brief answer. 8542. What is the difference between the Number of enrolments of both sexes in Secondary in 1995 and the Number of enrolments of both sexes in Secondary vocational in 1997?
Ensure brevity in your answer.  1.03e+05. What is the difference between the Number of enrolments of both sexes of Secondary general in 1995 and the Number of enrolments of both sexes of Secondary vocational in 1997?
Offer a very short reply. 3.75e+04. What is the difference between the Number of enrolments of both sexes in Primary in 1995 and the Number of enrolments of both sexes in Secondary in 1998?
Your answer should be very brief. 3.77e+05. What is the difference between the Number of enrolments of both sexes of Primary in 1995 and the Number of enrolments of both sexes of Secondary general in 1998?
Provide a short and direct response. 4.16e+05. What is the difference between the Number of enrolments of both sexes of Primary in 1995 and the Number of enrolments of both sexes of Secondary vocational in 1998?
Offer a very short reply. 5.18e+05. What is the difference between the Number of enrolments of both sexes in Secondary in 1995 and the Number of enrolments of both sexes in Secondary general in 1998?
Offer a terse response. 251. What is the difference between the Number of enrolments of both sexes of Secondary in 1995 and the Number of enrolments of both sexes of Secondary vocational in 1998?
Offer a terse response. 1.02e+05. What is the difference between the Number of enrolments of both sexes in Secondary general in 1995 and the Number of enrolments of both sexes in Secondary vocational in 1998?
Ensure brevity in your answer.  3.61e+04. What is the difference between the Number of enrolments of both sexes of Primary in 1995 and the Number of enrolments of both sexes of Secondary in 1999?
Keep it short and to the point. 3.59e+05. What is the difference between the Number of enrolments of both sexes in Primary in 1995 and the Number of enrolments of both sexes in Secondary general in 1999?
Ensure brevity in your answer.  4.11e+05. What is the difference between the Number of enrolments of both sexes in Primary in 1995 and the Number of enrolments of both sexes in Secondary vocational in 1999?
Offer a very short reply. 5.18e+05. What is the difference between the Number of enrolments of both sexes of Secondary in 1995 and the Number of enrolments of both sexes of Secondary general in 1999?
Offer a terse response. -5650. What is the difference between the Number of enrolments of both sexes in Secondary in 1995 and the Number of enrolments of both sexes in Secondary vocational in 1999?
Offer a very short reply. 1.02e+05. What is the difference between the Number of enrolments of both sexes of Secondary general in 1995 and the Number of enrolments of both sexes of Secondary vocational in 1999?
Make the answer very short. 3.58e+04. What is the difference between the Number of enrolments of both sexes in Primary in 1995 and the Number of enrolments of both sexes in Secondary in 2000?
Your answer should be very brief. 3.37e+05. What is the difference between the Number of enrolments of both sexes of Primary in 1995 and the Number of enrolments of both sexes of Secondary general in 2000?
Give a very brief answer. 3.89e+05. What is the difference between the Number of enrolments of both sexes in Primary in 1995 and the Number of enrolments of both sexes in Secondary vocational in 2000?
Offer a terse response. 5.18e+05. What is the difference between the Number of enrolments of both sexes of Secondary in 1995 and the Number of enrolments of both sexes of Secondary general in 2000?
Your response must be concise. -2.73e+04. What is the difference between the Number of enrolments of both sexes in Secondary in 1995 and the Number of enrolments of both sexes in Secondary vocational in 2000?
Give a very brief answer. 1.02e+05. What is the difference between the Number of enrolments of both sexes of Secondary general in 1995 and the Number of enrolments of both sexes of Secondary vocational in 2000?
Your answer should be very brief. 3.57e+04. What is the difference between the Number of enrolments of both sexes in Primary in 1996 and the Number of enrolments of both sexes in Secondary in 1997?
Provide a succinct answer. 2.97e+05. What is the difference between the Number of enrolments of both sexes in Primary in 1996 and the Number of enrolments of both sexes in Secondary general in 1997?
Provide a short and direct response. 3.22e+05. What is the difference between the Number of enrolments of both sexes in Primary in 1996 and the Number of enrolments of both sexes in Secondary vocational in 1997?
Keep it short and to the point. 4.16e+05. What is the difference between the Number of enrolments of both sexes in Secondary in 1996 and the Number of enrolments of both sexes in Secondary general in 1997?
Your answer should be compact. 1.76e+04. What is the difference between the Number of enrolments of both sexes of Secondary in 1996 and the Number of enrolments of both sexes of Secondary vocational in 1997?
Ensure brevity in your answer.  1.12e+05. What is the difference between the Number of enrolments of both sexes of Secondary general in 1996 and the Number of enrolments of both sexes of Secondary vocational in 1997?
Your answer should be compact. 9.53e+04. What is the difference between the Number of enrolments of both sexes of Primary in 1996 and the Number of enrolments of both sexes of Secondary in 1998?
Ensure brevity in your answer.  2.74e+05. What is the difference between the Number of enrolments of both sexes in Primary in 1996 and the Number of enrolments of both sexes in Secondary general in 1998?
Your response must be concise. 3.13e+05. What is the difference between the Number of enrolments of both sexes in Primary in 1996 and the Number of enrolments of both sexes in Secondary vocational in 1998?
Give a very brief answer. 4.15e+05. What is the difference between the Number of enrolments of both sexes of Secondary in 1996 and the Number of enrolments of both sexes of Secondary general in 1998?
Offer a very short reply. 9293. What is the difference between the Number of enrolments of both sexes in Secondary in 1996 and the Number of enrolments of both sexes in Secondary vocational in 1998?
Make the answer very short. 1.11e+05. What is the difference between the Number of enrolments of both sexes in Secondary general in 1996 and the Number of enrolments of both sexes in Secondary vocational in 1998?
Your answer should be compact. 9.40e+04. What is the difference between the Number of enrolments of both sexes of Primary in 1996 and the Number of enrolments of both sexes of Secondary in 1999?
Keep it short and to the point. 2.55e+05. What is the difference between the Number of enrolments of both sexes of Primary in 1996 and the Number of enrolments of both sexes of Secondary general in 1999?
Make the answer very short. 3.07e+05. What is the difference between the Number of enrolments of both sexes of Primary in 1996 and the Number of enrolments of both sexes of Secondary vocational in 1999?
Provide a short and direct response. 4.15e+05. What is the difference between the Number of enrolments of both sexes in Secondary in 1996 and the Number of enrolments of both sexes in Secondary general in 1999?
Your answer should be very brief. 3392. What is the difference between the Number of enrolments of both sexes in Secondary in 1996 and the Number of enrolments of both sexes in Secondary vocational in 1999?
Your response must be concise. 1.11e+05. What is the difference between the Number of enrolments of both sexes in Secondary general in 1996 and the Number of enrolments of both sexes in Secondary vocational in 1999?
Keep it short and to the point. 9.36e+04. What is the difference between the Number of enrolments of both sexes of Primary in 1996 and the Number of enrolments of both sexes of Secondary in 2000?
Your response must be concise. 2.34e+05. What is the difference between the Number of enrolments of both sexes in Primary in 1996 and the Number of enrolments of both sexes in Secondary general in 2000?
Provide a succinct answer. 2.86e+05. What is the difference between the Number of enrolments of both sexes of Primary in 1996 and the Number of enrolments of both sexes of Secondary vocational in 2000?
Keep it short and to the point. 4.15e+05. What is the difference between the Number of enrolments of both sexes of Secondary in 1996 and the Number of enrolments of both sexes of Secondary general in 2000?
Offer a very short reply. -1.83e+04. What is the difference between the Number of enrolments of both sexes in Secondary in 1996 and the Number of enrolments of both sexes in Secondary vocational in 2000?
Keep it short and to the point. 1.11e+05. What is the difference between the Number of enrolments of both sexes of Secondary general in 1996 and the Number of enrolments of both sexes of Secondary vocational in 2000?
Offer a very short reply. 9.36e+04. What is the difference between the Number of enrolments of both sexes in Primary in 1997 and the Number of enrolments of both sexes in Secondary in 1998?
Offer a very short reply. 3.01e+05. What is the difference between the Number of enrolments of both sexes of Primary in 1997 and the Number of enrolments of both sexes of Secondary general in 1998?
Provide a short and direct response. 3.41e+05. What is the difference between the Number of enrolments of both sexes in Primary in 1997 and the Number of enrolments of both sexes in Secondary vocational in 1998?
Give a very brief answer. 4.42e+05. What is the difference between the Number of enrolments of both sexes in Secondary in 1997 and the Number of enrolments of both sexes in Secondary general in 1998?
Make the answer very short. 1.60e+04. What is the difference between the Number of enrolments of both sexes in Secondary in 1997 and the Number of enrolments of both sexes in Secondary vocational in 1998?
Make the answer very short. 1.18e+05. What is the difference between the Number of enrolments of both sexes in Secondary general in 1997 and the Number of enrolments of both sexes in Secondary vocational in 1998?
Provide a succinct answer. 9.34e+04. What is the difference between the Number of enrolments of both sexes of Primary in 1997 and the Number of enrolments of both sexes of Secondary in 1999?
Your response must be concise. 2.83e+05. What is the difference between the Number of enrolments of both sexes in Primary in 1997 and the Number of enrolments of both sexes in Secondary general in 1999?
Offer a terse response. 3.35e+05. What is the difference between the Number of enrolments of both sexes of Primary in 1997 and the Number of enrolments of both sexes of Secondary vocational in 1999?
Offer a terse response. 4.42e+05. What is the difference between the Number of enrolments of both sexes of Secondary in 1997 and the Number of enrolments of both sexes of Secondary general in 1999?
Your answer should be very brief. 1.01e+04. What is the difference between the Number of enrolments of both sexes of Secondary in 1997 and the Number of enrolments of both sexes of Secondary vocational in 1999?
Provide a short and direct response. 1.17e+05. What is the difference between the Number of enrolments of both sexes in Secondary general in 1997 and the Number of enrolments of both sexes in Secondary vocational in 1999?
Provide a succinct answer. 9.30e+04. What is the difference between the Number of enrolments of both sexes in Primary in 1997 and the Number of enrolments of both sexes in Secondary in 2000?
Provide a short and direct response. 2.61e+05. What is the difference between the Number of enrolments of both sexes in Primary in 1997 and the Number of enrolments of both sexes in Secondary general in 2000?
Provide a succinct answer. 3.13e+05. What is the difference between the Number of enrolments of both sexes in Primary in 1997 and the Number of enrolments of both sexes in Secondary vocational in 2000?
Keep it short and to the point. 4.42e+05. What is the difference between the Number of enrolments of both sexes in Secondary in 1997 and the Number of enrolments of both sexes in Secondary general in 2000?
Keep it short and to the point. -1.15e+04. What is the difference between the Number of enrolments of both sexes in Secondary in 1997 and the Number of enrolments of both sexes in Secondary vocational in 2000?
Provide a succinct answer. 1.17e+05. What is the difference between the Number of enrolments of both sexes in Secondary general in 1997 and the Number of enrolments of both sexes in Secondary vocational in 2000?
Your answer should be compact. 9.30e+04. What is the difference between the Number of enrolments of both sexes of Primary in 1998 and the Number of enrolments of both sexes of Secondary in 1999?
Your answer should be compact. 3.84e+05. What is the difference between the Number of enrolments of both sexes of Primary in 1998 and the Number of enrolments of both sexes of Secondary general in 1999?
Offer a very short reply. 4.36e+05. What is the difference between the Number of enrolments of both sexes of Primary in 1998 and the Number of enrolments of both sexes of Secondary vocational in 1999?
Provide a short and direct response. 5.43e+05. What is the difference between the Number of enrolments of both sexes in Secondary in 1998 and the Number of enrolments of both sexes in Secondary general in 1999?
Offer a terse response. 3.32e+04. What is the difference between the Number of enrolments of both sexes of Secondary in 1998 and the Number of enrolments of both sexes of Secondary vocational in 1999?
Offer a terse response. 1.40e+05. What is the difference between the Number of enrolments of both sexes of Secondary general in 1998 and the Number of enrolments of both sexes of Secondary vocational in 1999?
Your response must be concise. 1.01e+05. What is the difference between the Number of enrolments of both sexes of Primary in 1998 and the Number of enrolments of both sexes of Secondary in 2000?
Your response must be concise. 3.63e+05. What is the difference between the Number of enrolments of both sexes of Primary in 1998 and the Number of enrolments of both sexes of Secondary general in 2000?
Make the answer very short. 4.14e+05. What is the difference between the Number of enrolments of both sexes in Primary in 1998 and the Number of enrolments of both sexes in Secondary vocational in 2000?
Give a very brief answer. 5.43e+05. What is the difference between the Number of enrolments of both sexes of Secondary in 1998 and the Number of enrolments of both sexes of Secondary general in 2000?
Provide a succinct answer. 1.15e+04. What is the difference between the Number of enrolments of both sexes of Secondary in 1998 and the Number of enrolments of both sexes of Secondary vocational in 2000?
Ensure brevity in your answer.  1.40e+05. What is the difference between the Number of enrolments of both sexes in Secondary general in 1998 and the Number of enrolments of both sexes in Secondary vocational in 2000?
Offer a terse response. 1.01e+05. What is the difference between the Number of enrolments of both sexes in Primary in 1999 and the Number of enrolments of both sexes in Secondary in 2000?
Provide a succinct answer. 4.79e+05. What is the difference between the Number of enrolments of both sexes of Primary in 1999 and the Number of enrolments of both sexes of Secondary general in 2000?
Your answer should be compact. 5.30e+05. What is the difference between the Number of enrolments of both sexes in Primary in 1999 and the Number of enrolments of both sexes in Secondary vocational in 2000?
Give a very brief answer. 6.59e+05. What is the difference between the Number of enrolments of both sexes in Secondary in 1999 and the Number of enrolments of both sexes in Secondary general in 2000?
Give a very brief answer. 3.04e+04. What is the difference between the Number of enrolments of both sexes of Secondary in 1999 and the Number of enrolments of both sexes of Secondary vocational in 2000?
Your answer should be compact. 1.59e+05. What is the difference between the Number of enrolments of both sexes in Secondary general in 1999 and the Number of enrolments of both sexes in Secondary vocational in 2000?
Provide a short and direct response. 1.07e+05. What is the average Number of enrolments of both sexes of Primary per year?
Your response must be concise. 5.84e+05. What is the average Number of enrolments of both sexes in Secondary per year?
Ensure brevity in your answer.  1.14e+05. What is the average Number of enrolments of both sexes of Secondary general per year?
Your answer should be compact. 8.38e+04. What is the average Number of enrolments of both sexes of Secondary vocational per year?
Your answer should be very brief. 9787.78. In the year 1991, what is the difference between the Number of enrolments of both sexes in Primary and Number of enrolments of both sexes in Secondary?
Give a very brief answer. 5.89e+05. In the year 1991, what is the difference between the Number of enrolments of both sexes in Primary and Number of enrolments of both sexes in Secondary general?
Provide a succinct answer. 5.96e+05. In the year 1991, what is the difference between the Number of enrolments of both sexes in Primary and Number of enrolments of both sexes in Secondary vocational?
Your answer should be very brief. 6.26e+05. In the year 1991, what is the difference between the Number of enrolments of both sexes of Secondary and Number of enrolments of both sexes of Secondary general?
Provide a short and direct response. 7434. In the year 1991, what is the difference between the Number of enrolments of both sexes in Secondary and Number of enrolments of both sexes in Secondary vocational?
Make the answer very short. 3.68e+04. In the year 1991, what is the difference between the Number of enrolments of both sexes in Secondary general and Number of enrolments of both sexes in Secondary vocational?
Your answer should be compact. 2.93e+04. In the year 1992, what is the difference between the Number of enrolments of both sexes of Primary and Number of enrolments of both sexes of Secondary?
Ensure brevity in your answer.  5.83e+05. In the year 1992, what is the difference between the Number of enrolments of both sexes of Primary and Number of enrolments of both sexes of Secondary general?
Your response must be concise. 5.91e+05. In the year 1992, what is the difference between the Number of enrolments of both sexes of Primary and Number of enrolments of both sexes of Secondary vocational?
Make the answer very short. 6.23e+05. In the year 1992, what is the difference between the Number of enrolments of both sexes in Secondary and Number of enrolments of both sexes in Secondary general?
Your response must be concise. 8064. In the year 1992, what is the difference between the Number of enrolments of both sexes of Secondary and Number of enrolments of both sexes of Secondary vocational?
Make the answer very short. 4.03e+04. In the year 1992, what is the difference between the Number of enrolments of both sexes in Secondary general and Number of enrolments of both sexes in Secondary vocational?
Your answer should be compact. 3.23e+04. In the year 1993, what is the difference between the Number of enrolments of both sexes of Primary and Number of enrolments of both sexes of Secondary?
Provide a short and direct response. 5.95e+05. In the year 1993, what is the difference between the Number of enrolments of both sexes in Primary and Number of enrolments of both sexes in Secondary general?
Keep it short and to the point. 6.05e+05. In the year 1993, what is the difference between the Number of enrolments of both sexes of Primary and Number of enrolments of both sexes of Secondary vocational?
Make the answer very short. 6.42e+05. In the year 1993, what is the difference between the Number of enrolments of both sexes in Secondary and Number of enrolments of both sexes in Secondary general?
Your answer should be compact. 9332. In the year 1993, what is the difference between the Number of enrolments of both sexes of Secondary and Number of enrolments of both sexes of Secondary vocational?
Your answer should be very brief. 4.64e+04. In the year 1993, what is the difference between the Number of enrolments of both sexes of Secondary general and Number of enrolments of both sexes of Secondary vocational?
Your answer should be very brief. 3.70e+04. In the year 1995, what is the difference between the Number of enrolments of both sexes of Primary and Number of enrolments of both sexes of Secondary?
Provide a short and direct response. 4.16e+05. In the year 1995, what is the difference between the Number of enrolments of both sexes in Primary and Number of enrolments of both sexes in Secondary general?
Your response must be concise. 4.82e+05. In the year 1995, what is the difference between the Number of enrolments of both sexes of Primary and Number of enrolments of both sexes of Secondary vocational?
Make the answer very short. 5.21e+05. In the year 1995, what is the difference between the Number of enrolments of both sexes of Secondary and Number of enrolments of both sexes of Secondary general?
Offer a terse response. 6.58e+04. In the year 1995, what is the difference between the Number of enrolments of both sexes of Secondary and Number of enrolments of both sexes of Secondary vocational?
Keep it short and to the point. 1.05e+05. In the year 1995, what is the difference between the Number of enrolments of both sexes in Secondary general and Number of enrolments of both sexes in Secondary vocational?
Provide a succinct answer. 3.91e+04. In the year 1996, what is the difference between the Number of enrolments of both sexes in Primary and Number of enrolments of both sexes in Secondary?
Offer a very short reply. 3.04e+05. In the year 1996, what is the difference between the Number of enrolments of both sexes in Primary and Number of enrolments of both sexes in Secondary general?
Your answer should be compact. 3.21e+05. In the year 1996, what is the difference between the Number of enrolments of both sexes of Primary and Number of enrolments of both sexes of Secondary vocational?
Offer a terse response. 4.17e+05. In the year 1996, what is the difference between the Number of enrolments of both sexes of Secondary and Number of enrolments of both sexes of Secondary general?
Ensure brevity in your answer.  1.70e+04. In the year 1996, what is the difference between the Number of enrolments of both sexes of Secondary and Number of enrolments of both sexes of Secondary vocational?
Keep it short and to the point. 1.13e+05. In the year 1996, what is the difference between the Number of enrolments of both sexes of Secondary general and Number of enrolments of both sexes of Secondary vocational?
Ensure brevity in your answer.  9.62e+04. In the year 1997, what is the difference between the Number of enrolments of both sexes of Primary and Number of enrolments of both sexes of Secondary?
Provide a succinct answer. 3.25e+05. In the year 1997, what is the difference between the Number of enrolments of both sexes of Primary and Number of enrolments of both sexes of Secondary general?
Provide a short and direct response. 3.49e+05. In the year 1997, what is the difference between the Number of enrolments of both sexes in Primary and Number of enrolments of both sexes in Secondary vocational?
Your answer should be compact. 4.44e+05. In the year 1997, what is the difference between the Number of enrolments of both sexes of Secondary and Number of enrolments of both sexes of Secondary general?
Offer a terse response. 2.43e+04. In the year 1997, what is the difference between the Number of enrolments of both sexes of Secondary and Number of enrolments of both sexes of Secondary vocational?
Offer a terse response. 1.19e+05. In the year 1997, what is the difference between the Number of enrolments of both sexes in Secondary general and Number of enrolments of both sexes in Secondary vocational?
Your answer should be compact. 9.48e+04. In the year 1998, what is the difference between the Number of enrolments of both sexes of Primary and Number of enrolments of both sexes of Secondary?
Your response must be concise. 4.03e+05. In the year 1998, what is the difference between the Number of enrolments of both sexes in Primary and Number of enrolments of both sexes in Secondary general?
Provide a short and direct response. 4.42e+05. In the year 1998, what is the difference between the Number of enrolments of both sexes in Primary and Number of enrolments of both sexes in Secondary vocational?
Ensure brevity in your answer.  5.43e+05. In the year 1998, what is the difference between the Number of enrolments of both sexes in Secondary and Number of enrolments of both sexes in Secondary general?
Your response must be concise. 3.91e+04. In the year 1998, what is the difference between the Number of enrolments of both sexes of Secondary and Number of enrolments of both sexes of Secondary vocational?
Offer a very short reply. 1.41e+05. In the year 1998, what is the difference between the Number of enrolments of both sexes of Secondary general and Number of enrolments of both sexes of Secondary vocational?
Ensure brevity in your answer.  1.02e+05. In the year 1999, what is the difference between the Number of enrolments of both sexes of Primary and Number of enrolments of both sexes of Secondary?
Your answer should be very brief. 5.00e+05. In the year 1999, what is the difference between the Number of enrolments of both sexes of Primary and Number of enrolments of both sexes of Secondary general?
Give a very brief answer. 5.52e+05. In the year 1999, what is the difference between the Number of enrolments of both sexes of Primary and Number of enrolments of both sexes of Secondary vocational?
Your answer should be compact. 6.59e+05. In the year 1999, what is the difference between the Number of enrolments of both sexes in Secondary and Number of enrolments of both sexes in Secondary general?
Your answer should be compact. 5.20e+04. In the year 1999, what is the difference between the Number of enrolments of both sexes in Secondary and Number of enrolments of both sexes in Secondary vocational?
Ensure brevity in your answer.  1.59e+05. In the year 1999, what is the difference between the Number of enrolments of both sexes of Secondary general and Number of enrolments of both sexes of Secondary vocational?
Provide a short and direct response. 1.07e+05. In the year 2000, what is the difference between the Number of enrolments of both sexes of Primary and Number of enrolments of both sexes of Secondary?
Your response must be concise. 5.12e+05. In the year 2000, what is the difference between the Number of enrolments of both sexes in Primary and Number of enrolments of both sexes in Secondary general?
Provide a short and direct response. 5.64e+05. In the year 2000, what is the difference between the Number of enrolments of both sexes in Primary and Number of enrolments of both sexes in Secondary vocational?
Ensure brevity in your answer.  6.93e+05. In the year 2000, what is the difference between the Number of enrolments of both sexes in Secondary and Number of enrolments of both sexes in Secondary general?
Keep it short and to the point. 5.16e+04. In the year 2000, what is the difference between the Number of enrolments of both sexes in Secondary and Number of enrolments of both sexes in Secondary vocational?
Make the answer very short. 1.80e+05. In the year 2000, what is the difference between the Number of enrolments of both sexes in Secondary general and Number of enrolments of both sexes in Secondary vocational?
Ensure brevity in your answer.  1.29e+05. What is the ratio of the Number of enrolments of both sexes of Primary in 1991 to that in 1992?
Ensure brevity in your answer.  1. What is the ratio of the Number of enrolments of both sexes in Secondary in 1991 to that in 1992?
Keep it short and to the point. 0.91. What is the ratio of the Number of enrolments of both sexes of Secondary general in 1991 to that in 1992?
Provide a short and direct response. 0.91. What is the ratio of the Number of enrolments of both sexes in Secondary vocational in 1991 to that in 1992?
Your answer should be very brief. 0.92. What is the ratio of the Number of enrolments of both sexes of Primary in 1991 to that in 1993?
Your answer should be compact. 0.97. What is the ratio of the Number of enrolments of both sexes of Secondary in 1991 to that in 1993?
Give a very brief answer. 0.79. What is the ratio of the Number of enrolments of both sexes of Secondary general in 1991 to that in 1993?
Your answer should be very brief. 0.79. What is the ratio of the Number of enrolments of both sexes in Secondary vocational in 1991 to that in 1993?
Make the answer very short. 0.8. What is the ratio of the Number of enrolments of both sexes in Primary in 1991 to that in 1995?
Offer a very short reply. 1.2. What is the ratio of the Number of enrolments of both sexes in Secondary in 1991 to that in 1995?
Give a very brief answer. 0.39. What is the ratio of the Number of enrolments of both sexes in Secondary general in 1991 to that in 1995?
Make the answer very short. 0.77. What is the ratio of the Number of enrolments of both sexes of Secondary vocational in 1991 to that in 1995?
Offer a very short reply. 0.87. What is the ratio of the Number of enrolments of both sexes of Primary in 1991 to that in 1996?
Give a very brief answer. 1.48. What is the ratio of the Number of enrolments of both sexes in Secondary in 1991 to that in 1996?
Give a very brief answer. 0.36. What is the ratio of the Number of enrolments of both sexes of Secondary general in 1991 to that in 1996?
Your response must be concise. 0.35. What is the ratio of the Number of enrolments of both sexes in Primary in 1991 to that in 1997?
Your answer should be compact. 1.4. What is the ratio of the Number of enrolments of both sexes of Secondary in 1991 to that in 1997?
Your answer should be very brief. 0.34. What is the ratio of the Number of enrolments of both sexes of Secondary general in 1991 to that in 1997?
Your answer should be compact. 0.35. What is the ratio of the Number of enrolments of both sexes of Secondary vocational in 1991 to that in 1997?
Your answer should be compact. 0.73. What is the ratio of the Number of enrolments of both sexes of Primary in 1991 to that in 1998?
Keep it short and to the point. 1.14. What is the ratio of the Number of enrolments of both sexes in Secondary in 1991 to that in 1998?
Give a very brief answer. 0.29. What is the ratio of the Number of enrolments of both sexes of Secondary general in 1991 to that in 1998?
Your response must be concise. 0.32. What is the ratio of the Number of enrolments of both sexes in Secondary vocational in 1991 to that in 1998?
Provide a short and direct response. 0.65. What is the ratio of the Number of enrolments of both sexes in Primary in 1991 to that in 1999?
Your answer should be compact. 0.94. What is the ratio of the Number of enrolments of both sexes in Secondary in 1991 to that in 1999?
Your response must be concise. 0.26. What is the ratio of the Number of enrolments of both sexes of Secondary general in 1991 to that in 1999?
Your answer should be very brief. 0.31. What is the ratio of the Number of enrolments of both sexes of Secondary vocational in 1991 to that in 1999?
Your response must be concise. 0.63. What is the ratio of the Number of enrolments of both sexes of Primary in 1991 to that in 2000?
Keep it short and to the point. 0.9. What is the ratio of the Number of enrolments of both sexes of Secondary in 1991 to that in 2000?
Your answer should be very brief. 0.23. What is the ratio of the Number of enrolments of both sexes in Secondary general in 1991 to that in 2000?
Provide a succinct answer. 0.26. What is the ratio of the Number of enrolments of both sexes of Secondary vocational in 1991 to that in 2000?
Offer a terse response. 0.62. What is the ratio of the Number of enrolments of both sexes in Primary in 1992 to that in 1993?
Your answer should be very brief. 0.97. What is the ratio of the Number of enrolments of both sexes of Secondary in 1992 to that in 1993?
Your response must be concise. 0.87. What is the ratio of the Number of enrolments of both sexes of Secondary general in 1992 to that in 1993?
Keep it short and to the point. 0.87. What is the ratio of the Number of enrolments of both sexes in Secondary vocational in 1992 to that in 1993?
Provide a succinct answer. 0.86. What is the ratio of the Number of enrolments of both sexes in Primary in 1992 to that in 1995?
Keep it short and to the point. 1.19. What is the ratio of the Number of enrolments of both sexes of Secondary in 1992 to that in 1995?
Offer a very short reply. 0.43. What is the ratio of the Number of enrolments of both sexes of Secondary general in 1992 to that in 1995?
Offer a terse response. 0.85. What is the ratio of the Number of enrolments of both sexes in Secondary vocational in 1992 to that in 1995?
Your answer should be very brief. 0.94. What is the ratio of the Number of enrolments of both sexes of Primary in 1992 to that in 1996?
Your response must be concise. 1.48. What is the ratio of the Number of enrolments of both sexes of Secondary in 1992 to that in 1996?
Your answer should be compact. 0.4. What is the ratio of the Number of enrolments of both sexes in Secondary general in 1992 to that in 1996?
Keep it short and to the point. 0.38. What is the ratio of the Number of enrolments of both sexes in Secondary vocational in 1992 to that in 1996?
Provide a succinct answer. 0.87. What is the ratio of the Number of enrolments of both sexes in Primary in 1992 to that in 1997?
Your response must be concise. 1.39. What is the ratio of the Number of enrolments of both sexes of Secondary in 1992 to that in 1997?
Provide a short and direct response. 0.37. What is the ratio of the Number of enrolments of both sexes in Secondary general in 1992 to that in 1997?
Provide a succinct answer. 0.38. What is the ratio of the Number of enrolments of both sexes of Secondary vocational in 1992 to that in 1997?
Your answer should be compact. 0.8. What is the ratio of the Number of enrolments of both sexes of Primary in 1992 to that in 1998?
Make the answer very short. 1.14. What is the ratio of the Number of enrolments of both sexes in Secondary in 1992 to that in 1998?
Provide a short and direct response. 0.32. What is the ratio of the Number of enrolments of both sexes in Secondary general in 1992 to that in 1998?
Give a very brief answer. 0.36. What is the ratio of the Number of enrolments of both sexes in Secondary vocational in 1992 to that in 1998?
Your answer should be very brief. 0.7. What is the ratio of the Number of enrolments of both sexes in Primary in 1992 to that in 1999?
Your answer should be very brief. 0.94. What is the ratio of the Number of enrolments of both sexes of Secondary in 1992 to that in 1999?
Make the answer very short. 0.28. What is the ratio of the Number of enrolments of both sexes of Secondary general in 1992 to that in 1999?
Offer a very short reply. 0.34. What is the ratio of the Number of enrolments of both sexes in Secondary vocational in 1992 to that in 1999?
Make the answer very short. 0.68. What is the ratio of the Number of enrolments of both sexes of Primary in 1992 to that in 2000?
Offer a very short reply. 0.9. What is the ratio of the Number of enrolments of both sexes in Secondary in 1992 to that in 2000?
Make the answer very short. 0.25. What is the ratio of the Number of enrolments of both sexes in Secondary general in 1992 to that in 2000?
Offer a terse response. 0.29. What is the ratio of the Number of enrolments of both sexes of Secondary vocational in 1992 to that in 2000?
Keep it short and to the point. 0.68. What is the ratio of the Number of enrolments of both sexes of Primary in 1993 to that in 1995?
Offer a terse response. 1.23. What is the ratio of the Number of enrolments of both sexes in Secondary in 1993 to that in 1995?
Offer a terse response. 0.49. What is the ratio of the Number of enrolments of both sexes of Secondary general in 1993 to that in 1995?
Provide a short and direct response. 0.97. What is the ratio of the Number of enrolments of both sexes in Secondary vocational in 1993 to that in 1995?
Your response must be concise. 1.09. What is the ratio of the Number of enrolments of both sexes of Primary in 1993 to that in 1996?
Make the answer very short. 1.53. What is the ratio of the Number of enrolments of both sexes in Secondary in 1993 to that in 1996?
Your answer should be compact. 0.45. What is the ratio of the Number of enrolments of both sexes of Secondary general in 1993 to that in 1996?
Give a very brief answer. 0.44. What is the ratio of the Number of enrolments of both sexes of Primary in 1993 to that in 1997?
Make the answer very short. 1.43. What is the ratio of the Number of enrolments of both sexes in Secondary in 1993 to that in 1997?
Give a very brief answer. 0.43. What is the ratio of the Number of enrolments of both sexes in Secondary general in 1993 to that in 1997?
Your response must be concise. 0.44. What is the ratio of the Number of enrolments of both sexes of Secondary vocational in 1993 to that in 1997?
Offer a terse response. 0.92. What is the ratio of the Number of enrolments of both sexes in Primary in 1993 to that in 1998?
Ensure brevity in your answer.  1.17. What is the ratio of the Number of enrolments of both sexes in Secondary in 1993 to that in 1998?
Provide a short and direct response. 0.37. What is the ratio of the Number of enrolments of both sexes of Secondary general in 1993 to that in 1998?
Offer a terse response. 0.41. What is the ratio of the Number of enrolments of both sexes of Secondary vocational in 1993 to that in 1998?
Provide a short and direct response. 0.81. What is the ratio of the Number of enrolments of both sexes in Primary in 1993 to that in 1999?
Your answer should be compact. 0.97. What is the ratio of the Number of enrolments of both sexes of Secondary in 1993 to that in 1999?
Provide a succinct answer. 0.33. What is the ratio of the Number of enrolments of both sexes of Secondary general in 1993 to that in 1999?
Give a very brief answer. 0.39. What is the ratio of the Number of enrolments of both sexes of Secondary vocational in 1993 to that in 1999?
Keep it short and to the point. 0.79. What is the ratio of the Number of enrolments of both sexes of Primary in 1993 to that in 2000?
Your response must be concise. 0.92. What is the ratio of the Number of enrolments of both sexes of Secondary in 1993 to that in 2000?
Offer a very short reply. 0.29. What is the ratio of the Number of enrolments of both sexes of Secondary general in 1993 to that in 2000?
Provide a succinct answer. 0.33. What is the ratio of the Number of enrolments of both sexes in Secondary vocational in 1993 to that in 2000?
Keep it short and to the point. 0.78. What is the ratio of the Number of enrolments of both sexes of Primary in 1995 to that in 1996?
Ensure brevity in your answer.  1.24. What is the ratio of the Number of enrolments of both sexes of Secondary in 1995 to that in 1996?
Offer a very short reply. 0.93. What is the ratio of the Number of enrolments of both sexes of Secondary general in 1995 to that in 1996?
Your answer should be compact. 0.45. What is the ratio of the Number of enrolments of both sexes of Secondary vocational in 1995 to that in 1996?
Your answer should be very brief. 0.92. What is the ratio of the Number of enrolments of both sexes in Primary in 1995 to that in 1997?
Make the answer very short. 1.17. What is the ratio of the Number of enrolments of both sexes of Secondary in 1995 to that in 1997?
Provide a short and direct response. 0.88. What is the ratio of the Number of enrolments of both sexes of Secondary general in 1995 to that in 1997?
Provide a short and direct response. 0.45. What is the ratio of the Number of enrolments of both sexes of Secondary vocational in 1995 to that in 1997?
Provide a short and direct response. 0.84. What is the ratio of the Number of enrolments of both sexes of Primary in 1995 to that in 1998?
Provide a short and direct response. 0.95. What is the ratio of the Number of enrolments of both sexes of Secondary in 1995 to that in 1998?
Ensure brevity in your answer.  0.74. What is the ratio of the Number of enrolments of both sexes of Secondary general in 1995 to that in 1998?
Provide a succinct answer. 0.42. What is the ratio of the Number of enrolments of both sexes in Secondary vocational in 1995 to that in 1998?
Offer a terse response. 0.74. What is the ratio of the Number of enrolments of both sexes of Primary in 1995 to that in 1999?
Your answer should be very brief. 0.79. What is the ratio of the Number of enrolments of both sexes in Secondary in 1995 to that in 1999?
Offer a very short reply. 0.66. What is the ratio of the Number of enrolments of both sexes in Secondary vocational in 1995 to that in 1999?
Keep it short and to the point. 0.72. What is the ratio of the Number of enrolments of both sexes in Primary in 1995 to that in 2000?
Offer a very short reply. 0.75. What is the ratio of the Number of enrolments of both sexes of Secondary in 1995 to that in 2000?
Your response must be concise. 0.59. What is the ratio of the Number of enrolments of both sexes of Secondary general in 1995 to that in 2000?
Provide a succinct answer. 0.34. What is the ratio of the Number of enrolments of both sexes of Secondary vocational in 1995 to that in 2000?
Your answer should be very brief. 0.72. What is the ratio of the Number of enrolments of both sexes in Primary in 1996 to that in 1997?
Give a very brief answer. 0.94. What is the ratio of the Number of enrolments of both sexes in Secondary in 1996 to that in 1997?
Make the answer very short. 0.95. What is the ratio of the Number of enrolments of both sexes of Secondary general in 1996 to that in 1997?
Provide a short and direct response. 1.01. What is the ratio of the Number of enrolments of both sexes of Secondary vocational in 1996 to that in 1997?
Your answer should be very brief. 0.92. What is the ratio of the Number of enrolments of both sexes of Primary in 1996 to that in 1998?
Keep it short and to the point. 0.77. What is the ratio of the Number of enrolments of both sexes of Secondary in 1996 to that in 1998?
Offer a very short reply. 0.8. What is the ratio of the Number of enrolments of both sexes in Secondary general in 1996 to that in 1998?
Offer a very short reply. 0.93. What is the ratio of the Number of enrolments of both sexes of Secondary vocational in 1996 to that in 1998?
Offer a terse response. 0.81. What is the ratio of the Number of enrolments of both sexes of Primary in 1996 to that in 1999?
Make the answer very short. 0.64. What is the ratio of the Number of enrolments of both sexes in Secondary in 1996 to that in 1999?
Your answer should be compact. 0.72. What is the ratio of the Number of enrolments of both sexes in Secondary general in 1996 to that in 1999?
Offer a terse response. 0.89. What is the ratio of the Number of enrolments of both sexes in Secondary vocational in 1996 to that in 1999?
Give a very brief answer. 0.78. What is the ratio of the Number of enrolments of both sexes in Primary in 1996 to that in 2000?
Your answer should be very brief. 0.61. What is the ratio of the Number of enrolments of both sexes of Secondary in 1996 to that in 2000?
Your response must be concise. 0.64. What is the ratio of the Number of enrolments of both sexes of Secondary general in 1996 to that in 2000?
Provide a short and direct response. 0.75. What is the ratio of the Number of enrolments of both sexes in Secondary vocational in 1996 to that in 2000?
Provide a succinct answer. 0.78. What is the ratio of the Number of enrolments of both sexes in Primary in 1997 to that in 1998?
Offer a terse response. 0.82. What is the ratio of the Number of enrolments of both sexes in Secondary in 1997 to that in 1998?
Give a very brief answer. 0.85. What is the ratio of the Number of enrolments of both sexes in Secondary general in 1997 to that in 1998?
Your answer should be compact. 0.93. What is the ratio of the Number of enrolments of both sexes in Secondary vocational in 1997 to that in 1998?
Ensure brevity in your answer.  0.88. What is the ratio of the Number of enrolments of both sexes of Primary in 1997 to that in 1999?
Make the answer very short. 0.68. What is the ratio of the Number of enrolments of both sexes in Secondary in 1997 to that in 1999?
Your answer should be very brief. 0.76. What is the ratio of the Number of enrolments of both sexes in Secondary general in 1997 to that in 1999?
Your answer should be very brief. 0.88. What is the ratio of the Number of enrolments of both sexes in Secondary vocational in 1997 to that in 1999?
Your answer should be compact. 0.85. What is the ratio of the Number of enrolments of both sexes in Primary in 1997 to that in 2000?
Offer a very short reply. 0.64. What is the ratio of the Number of enrolments of both sexes in Secondary in 1997 to that in 2000?
Give a very brief answer. 0.67. What is the ratio of the Number of enrolments of both sexes of Secondary general in 1997 to that in 2000?
Ensure brevity in your answer.  0.75. What is the ratio of the Number of enrolments of both sexes of Secondary vocational in 1997 to that in 2000?
Your response must be concise. 0.85. What is the ratio of the Number of enrolments of both sexes in Primary in 1998 to that in 1999?
Provide a short and direct response. 0.83. What is the ratio of the Number of enrolments of both sexes in Secondary in 1998 to that in 1999?
Keep it short and to the point. 0.89. What is the ratio of the Number of enrolments of both sexes of Secondary general in 1998 to that in 1999?
Ensure brevity in your answer.  0.95. What is the ratio of the Number of enrolments of both sexes of Secondary vocational in 1998 to that in 1999?
Give a very brief answer. 0.97. What is the ratio of the Number of enrolments of both sexes in Primary in 1998 to that in 2000?
Give a very brief answer. 0.79. What is the ratio of the Number of enrolments of both sexes of Secondary in 1998 to that in 2000?
Offer a terse response. 0.79. What is the ratio of the Number of enrolments of both sexes of Secondary general in 1998 to that in 2000?
Provide a short and direct response. 0.8. What is the ratio of the Number of enrolments of both sexes in Secondary vocational in 1998 to that in 2000?
Offer a terse response. 0.97. What is the ratio of the Number of enrolments of both sexes in Primary in 1999 to that in 2000?
Give a very brief answer. 0.95. What is the ratio of the Number of enrolments of both sexes of Secondary in 1999 to that in 2000?
Offer a terse response. 0.89. What is the ratio of the Number of enrolments of both sexes of Secondary general in 1999 to that in 2000?
Your answer should be very brief. 0.85. What is the ratio of the Number of enrolments of both sexes in Secondary vocational in 1999 to that in 2000?
Ensure brevity in your answer.  1. What is the difference between the highest and the second highest Number of enrolments of both sexes of Primary?
Give a very brief answer. 3.39e+04. What is the difference between the highest and the second highest Number of enrolments of both sexes of Secondary?
Your answer should be compact. 2.12e+04. What is the difference between the highest and the second highest Number of enrolments of both sexes of Secondary general?
Your response must be concise. 2.17e+04. What is the difference between the highest and the second highest Number of enrolments of both sexes of Secondary vocational?
Ensure brevity in your answer.  42. What is the difference between the highest and the lowest Number of enrolments of both sexes of Primary?
Keep it short and to the point. 2.78e+05. What is the difference between the highest and the lowest Number of enrolments of both sexes in Secondary?
Make the answer very short. 1.48e+05. What is the difference between the highest and the lowest Number of enrolments of both sexes in Secondary general?
Your answer should be very brief. 1.04e+05. What is the difference between the highest and the lowest Number of enrolments of both sexes of Secondary vocational?
Your answer should be compact. 4478. 